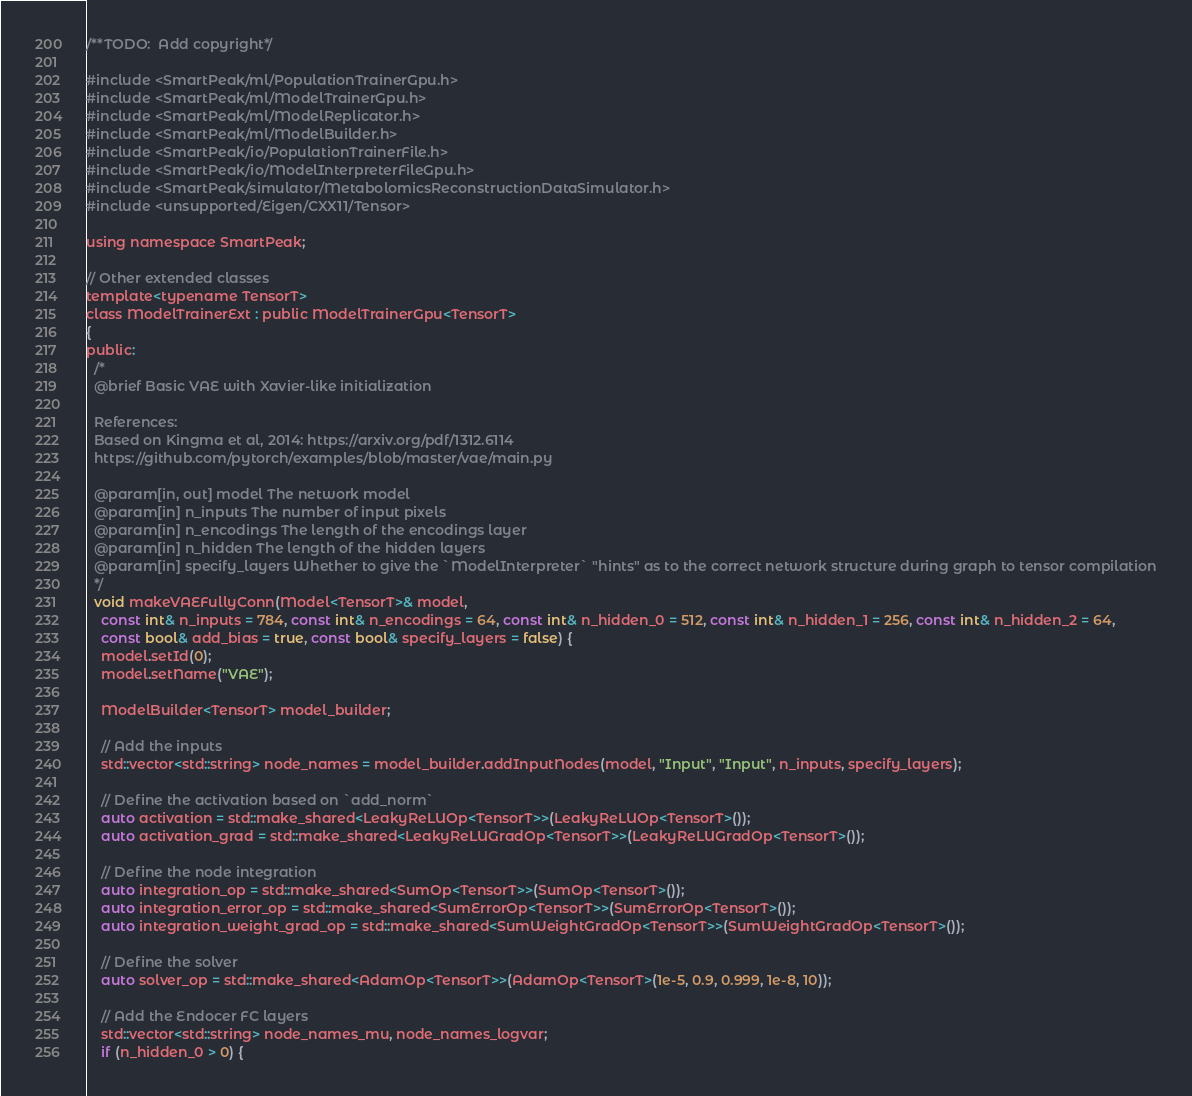<code> <loc_0><loc_0><loc_500><loc_500><_Cuda_>/**TODO:  Add copyright*/

#include <SmartPeak/ml/PopulationTrainerGpu.h>
#include <SmartPeak/ml/ModelTrainerGpu.h>
#include <SmartPeak/ml/ModelReplicator.h>
#include <SmartPeak/ml/ModelBuilder.h>
#include <SmartPeak/io/PopulationTrainerFile.h>
#include <SmartPeak/io/ModelInterpreterFileGpu.h>
#include <SmartPeak/simulator/MetabolomicsReconstructionDataSimulator.h>
#include <unsupported/Eigen/CXX11/Tensor>

using namespace SmartPeak;

// Other extended classes
template<typename TensorT>
class ModelTrainerExt : public ModelTrainerGpu<TensorT>
{
public:
  /*
  @brief Basic VAE with	Xavier-like initialization

  References:
  Based on Kingma et al, 2014: https://arxiv.org/pdf/1312.6114
  https://github.com/pytorch/examples/blob/master/vae/main.py

  @param[in, out] model The network model
  @param[in] n_inputs The number of input pixels
  @param[in] n_encodings The length of the encodings layer
  @param[in] n_hidden The length of the hidden layers
  @param[in] specify_layers Whether to give the `ModelInterpreter` "hints" as to the correct network structure during graph to tensor compilation
  */
  void makeVAEFullyConn(Model<TensorT>& model,
    const int& n_inputs = 784, const int& n_encodings = 64, const int& n_hidden_0 = 512, const int& n_hidden_1 = 256, const int& n_hidden_2 = 64,
    const bool& add_bias = true, const bool& specify_layers = false) {
    model.setId(0);
    model.setName("VAE");

    ModelBuilder<TensorT> model_builder;

    // Add the inputs
    std::vector<std::string> node_names = model_builder.addInputNodes(model, "Input", "Input", n_inputs, specify_layers);

    // Define the activation based on `add_norm`
    auto activation = std::make_shared<LeakyReLUOp<TensorT>>(LeakyReLUOp<TensorT>());
    auto activation_grad = std::make_shared<LeakyReLUGradOp<TensorT>>(LeakyReLUGradOp<TensorT>());

    // Define the node integration
    auto integration_op = std::make_shared<SumOp<TensorT>>(SumOp<TensorT>());
    auto integration_error_op = std::make_shared<SumErrorOp<TensorT>>(SumErrorOp<TensorT>());
    auto integration_weight_grad_op = std::make_shared<SumWeightGradOp<TensorT>>(SumWeightGradOp<TensorT>());

    // Define the solver
    auto solver_op = std::make_shared<AdamOp<TensorT>>(AdamOp<TensorT>(1e-5, 0.9, 0.999, 1e-8, 10));

    // Add the Endocer FC layers
    std::vector<std::string> node_names_mu, node_names_logvar;
    if (n_hidden_0 > 0) {</code> 